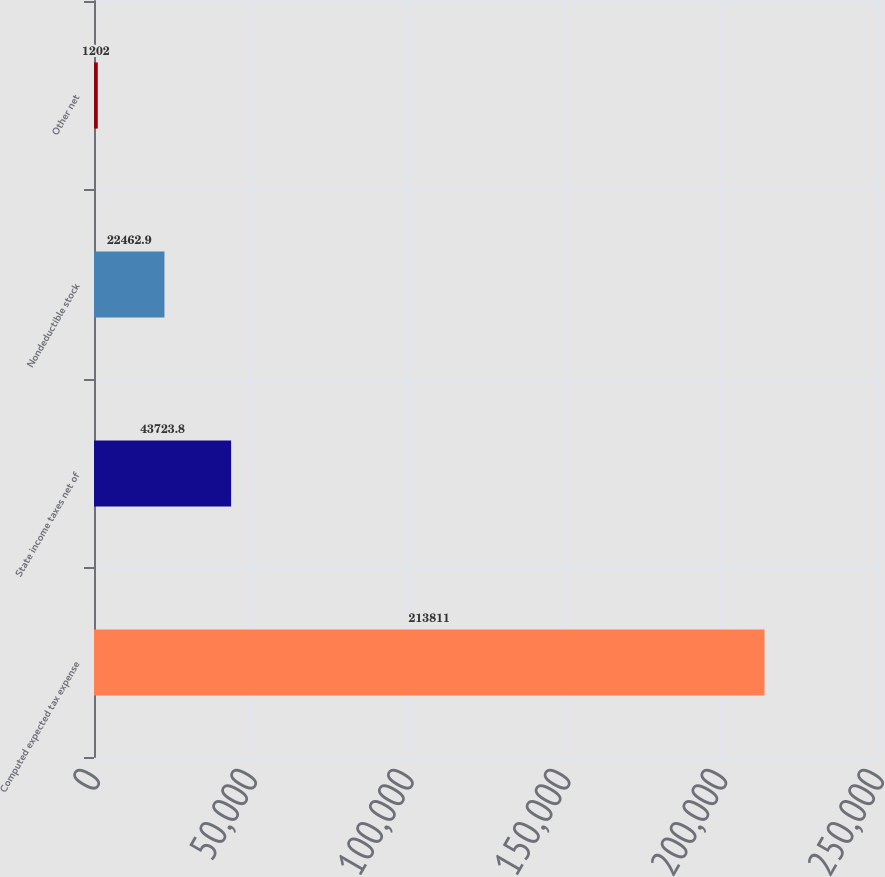<chart> <loc_0><loc_0><loc_500><loc_500><bar_chart><fcel>Computed expected tax expense<fcel>State income taxes net of<fcel>Nondeductible stock<fcel>Other net<nl><fcel>213811<fcel>43723.8<fcel>22462.9<fcel>1202<nl></chart> 